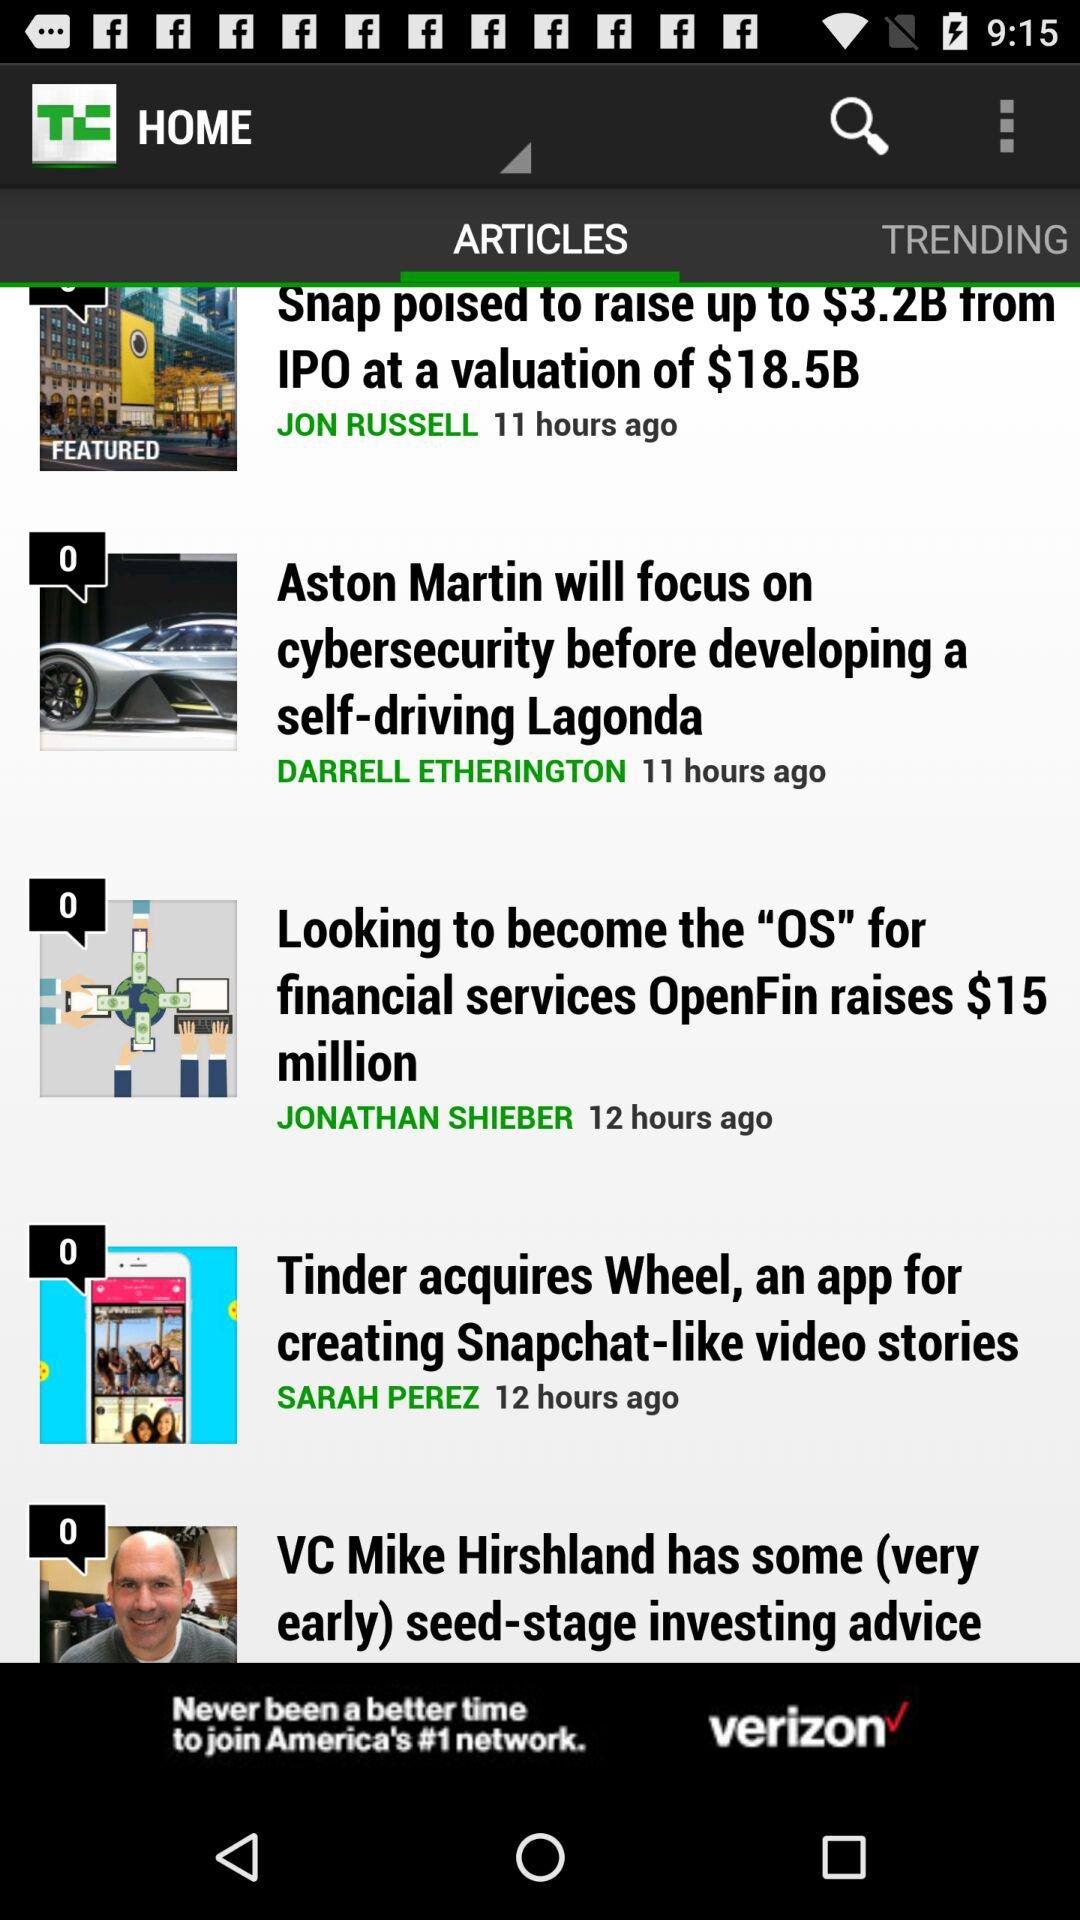Who is the author of the article "Looking to become the "OS" for financial services OpenFin raises $15 million"? The author of the article "Looking to become the "OS" for financial services OpenFin raises $15 million" is Jonathan Shieber. 